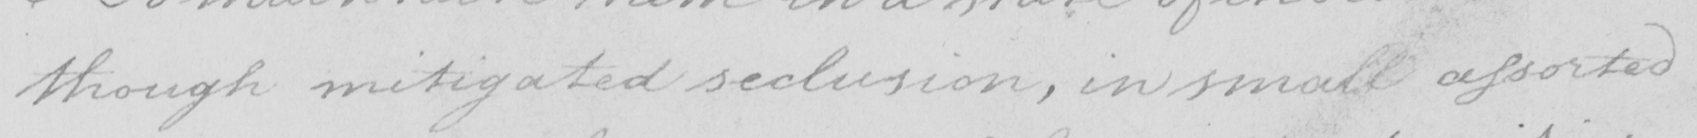Transcribe the text shown in this historical manuscript line. though mitigated seclusion , in small assorted 